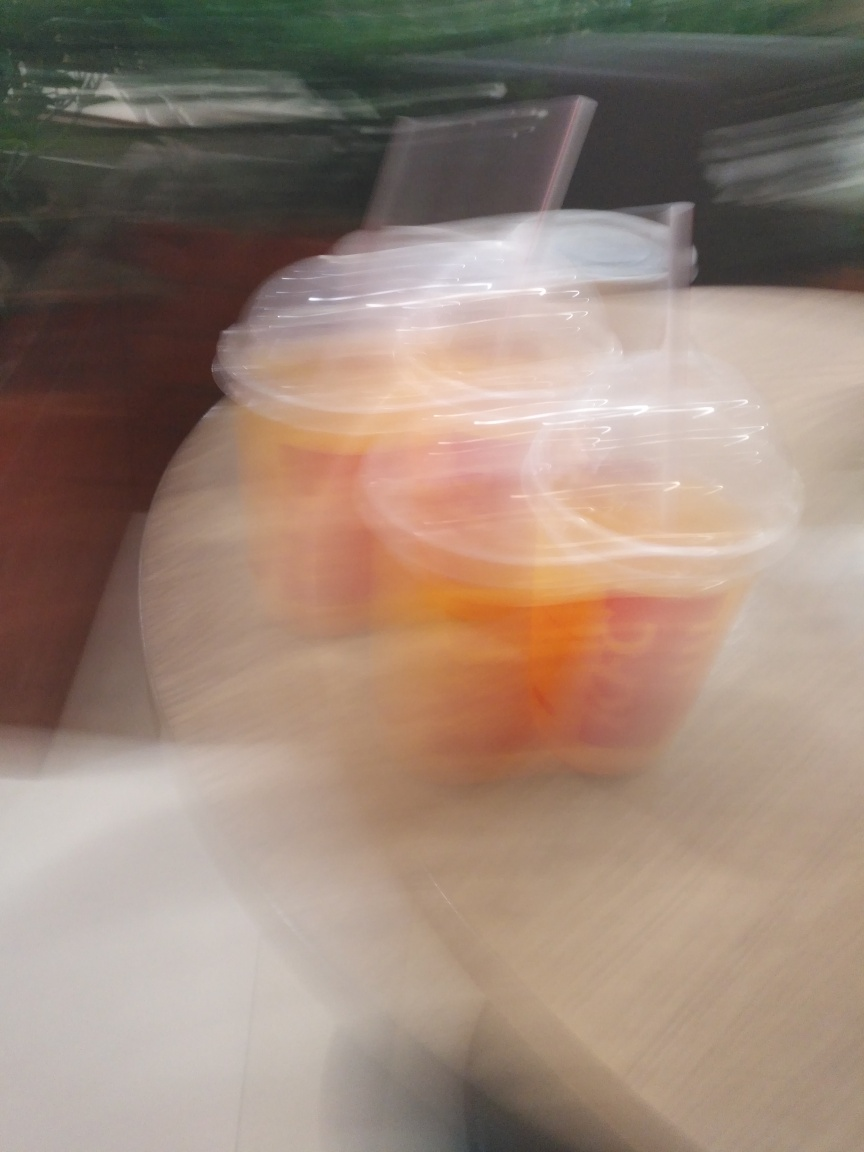What might have caused the blur in this photo? The blur in the photo likely resulted from movement, either of the subject or the camera, during the exposure time. This type of blur could indicate that the photo was taken hastily or that the camera was not held steady. Is there any way to tell what the subject of the photo is despite the blur? Despite the motion blur, one can identify that the subject might be some kind of beverage cups with lids on a table. However, the specifics, such as the type of beverages or the brand, are indistinguishable due to the lack of focused detail. 